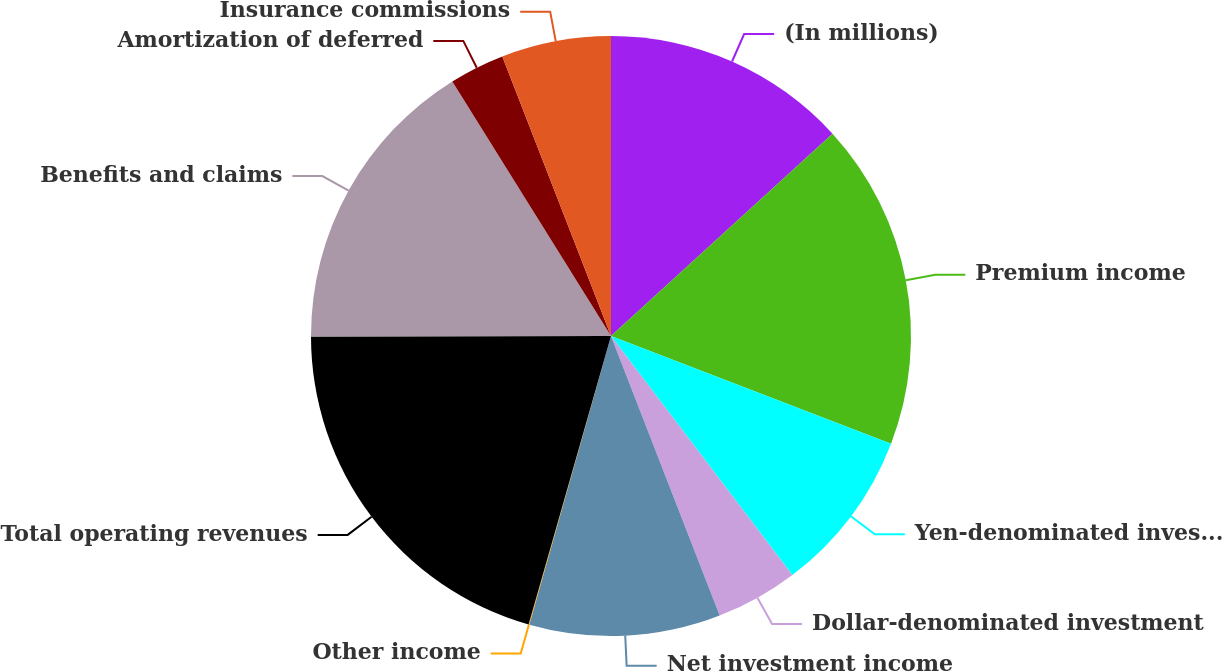<chart> <loc_0><loc_0><loc_500><loc_500><pie_chart><fcel>(In millions)<fcel>Premium income<fcel>Yen-denominated investment<fcel>Dollar-denominated investment<fcel>Net investment income<fcel>Other income<fcel>Total operating revenues<fcel>Benefits and claims<fcel>Amortization of deferred<fcel>Insurance commissions<nl><fcel>13.22%<fcel>17.62%<fcel>8.83%<fcel>4.43%<fcel>10.29%<fcel>0.04%<fcel>20.55%<fcel>16.15%<fcel>2.97%<fcel>5.9%<nl></chart> 